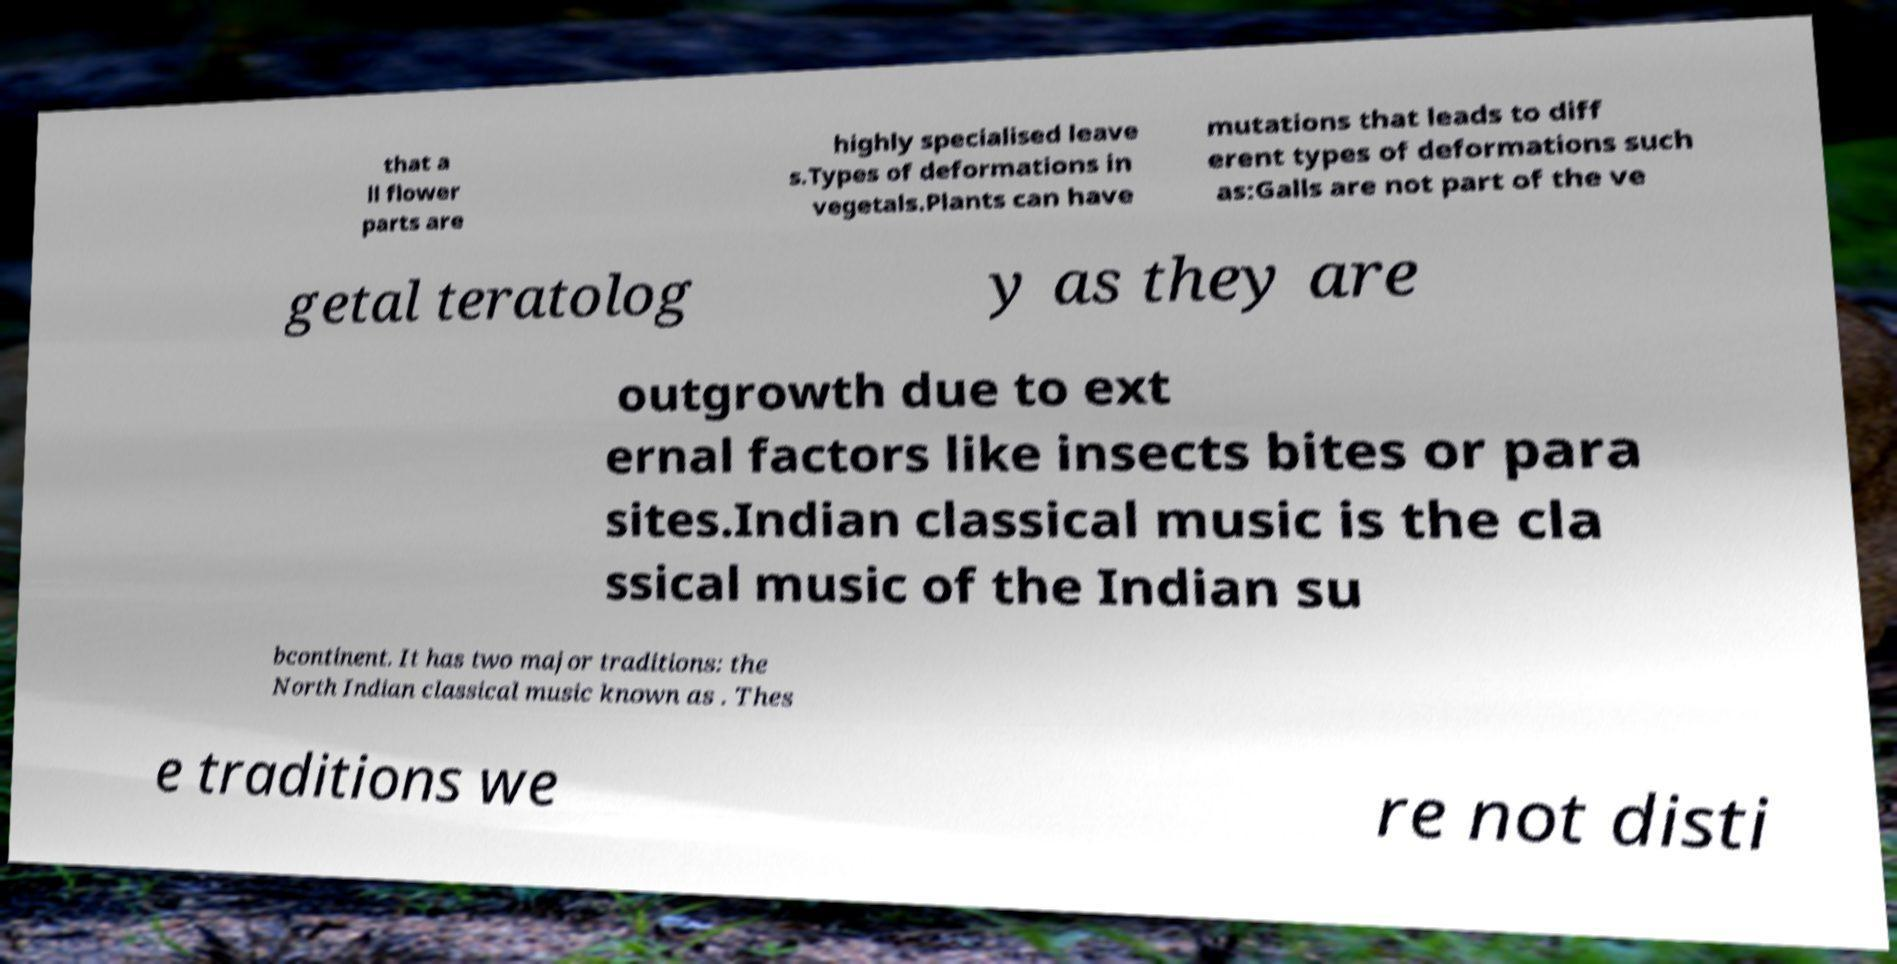There's text embedded in this image that I need extracted. Can you transcribe it verbatim? that a ll flower parts are highly specialised leave s.Types of deformations in vegetals.Plants can have mutations that leads to diff erent types of deformations such as:Galls are not part of the ve getal teratolog y as they are outgrowth due to ext ernal factors like insects bites or para sites.Indian classical music is the cla ssical music of the Indian su bcontinent. It has two major traditions: the North Indian classical music known as . Thes e traditions we re not disti 